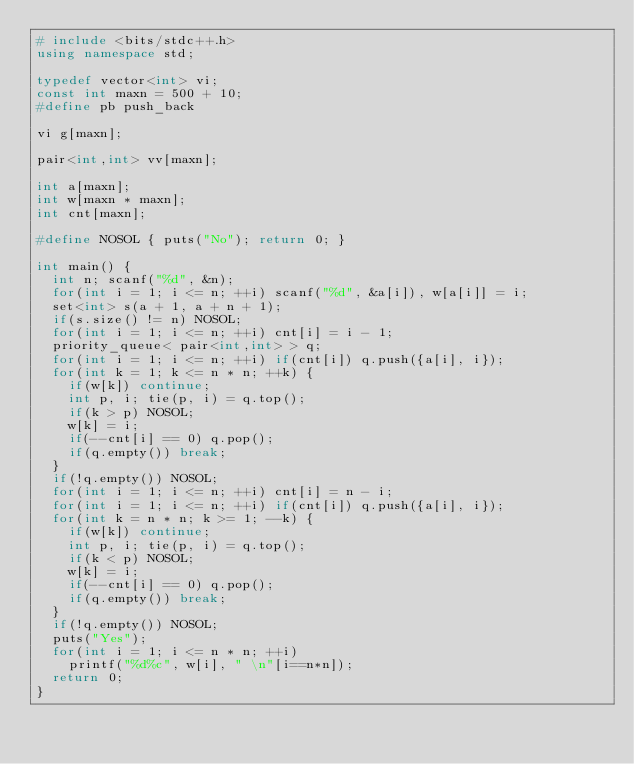Convert code to text. <code><loc_0><loc_0><loc_500><loc_500><_C++_># include <bits/stdc++.h>
using namespace std;
 
typedef vector<int> vi;
const int maxn = 500 + 10;
#define pb push_back
 
vi g[maxn];
 
pair<int,int> vv[maxn];
 
int a[maxn];
int w[maxn * maxn];
int cnt[maxn];
 
#define NOSOL { puts("No"); return 0; }
 
int main() {
	int n; scanf("%d", &n);
	for(int i = 1; i <= n; ++i) scanf("%d", &a[i]), w[a[i]] = i;
	set<int> s(a + 1, a + n + 1);
	if(s.size() != n) NOSOL;
	for(int i = 1; i <= n; ++i) cnt[i] = i - 1;
	priority_queue< pair<int,int> > q;
	for(int i = 1; i <= n; ++i) if(cnt[i]) q.push({a[i], i});
	for(int k = 1; k <= n * n; ++k) {
		if(w[k]) continue;
		int p, i; tie(p, i) = q.top();
		if(k > p) NOSOL;
		w[k] = i;
		if(--cnt[i] == 0) q.pop();
		if(q.empty()) break;
	}
	if(!q.empty()) NOSOL;
	for(int i = 1; i <= n; ++i) cnt[i] = n - i;
	for(int i = 1; i <= n; ++i) if(cnt[i]) q.push({a[i], i});
	for(int k = n * n; k >= 1; --k) {
		if(w[k]) continue;
		int p, i; tie(p, i) = q.top();
		if(k < p) NOSOL;
		w[k] = i;
		if(--cnt[i] == 0) q.pop();
		if(q.empty()) break;
	}
	if(!q.empty()) NOSOL;
	puts("Yes");
	for(int i = 1; i <= n * n; ++i) 
		printf("%d%c", w[i], " \n"[i==n*n]);
	return 0;
}</code> 